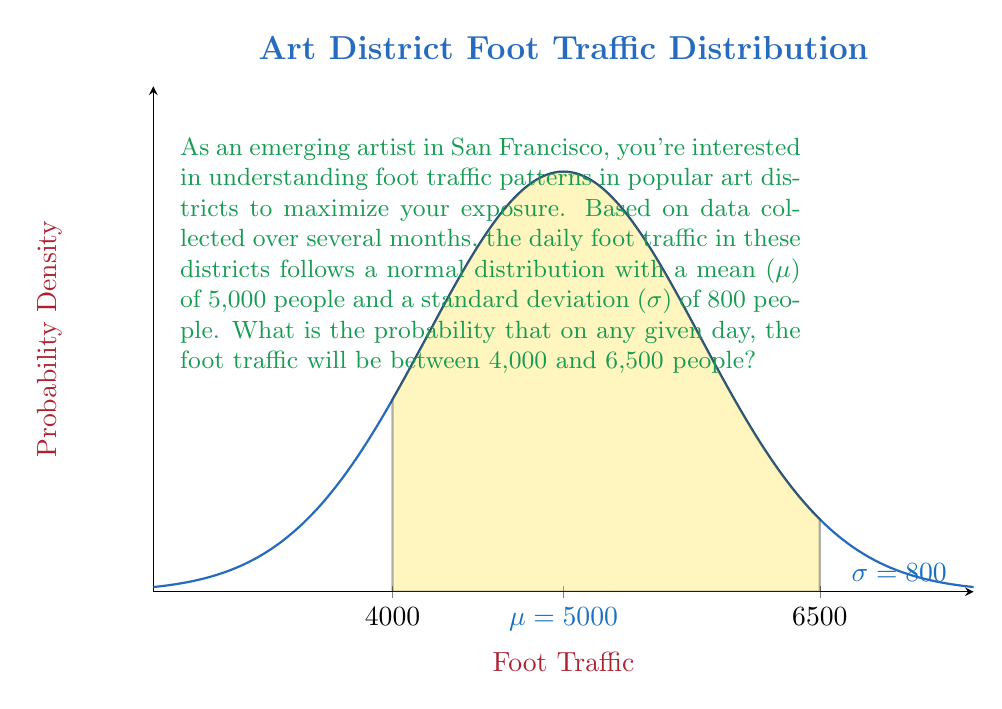Solve this math problem. To solve this problem, we'll use the standard normal distribution (z-score) method:

1) First, we need to calculate the z-scores for both limits:

   For 4,000 people: $z_1 = \frac{4000 - 5000}{800} = -1.25$
   For 6,500 people: $z_2 = \frac{6500 - 5000}{800} = 1.875$

2) Now, we need to find the area under the standard normal curve between these two z-scores.

3) We can use the standard normal table or a calculator to find:
   $P(Z < 1.875) = 0.9696$
   $P(Z < -1.25) = 0.1056$

4) The probability we're looking for is the difference between these two:
   $P(-1.25 < Z < 1.875) = 0.9696 - 0.1056 = 0.8640$

5) Therefore, the probability that the foot traffic will be between 4,000 and 6,500 people on any given day is approximately 0.8640 or 86.40%.

This high probability suggests that you're likely to encounter this range of foot traffic on most days, which is valuable information for planning your art displays or performances.
Answer: 0.8640 or 86.40% 